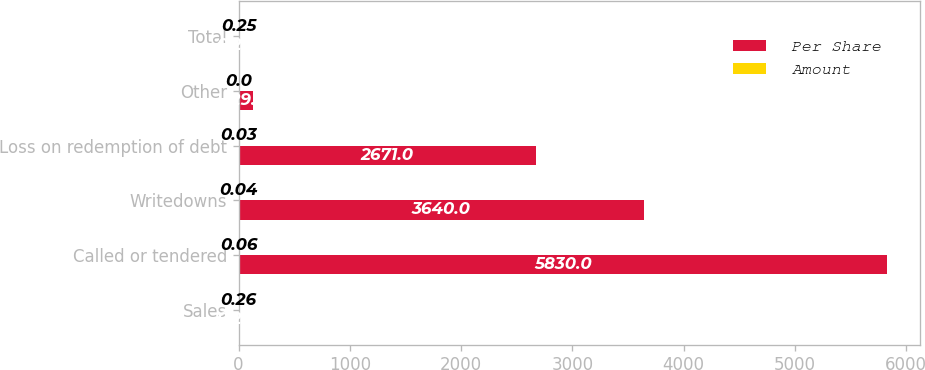<chart> <loc_0><loc_0><loc_500><loc_500><stacked_bar_chart><ecel><fcel>Sales<fcel>Called or tendered<fcel>Writedowns<fcel>Loss on redemption of debt<fcel>Other<fcel>Total<nl><fcel>Per Share<fcel>0.255<fcel>5830<fcel>3640<fcel>2671<fcel>129<fcel>0.255<nl><fcel>Amount<fcel>0.26<fcel>0.06<fcel>0.04<fcel>0.03<fcel>0<fcel>0.25<nl></chart> 